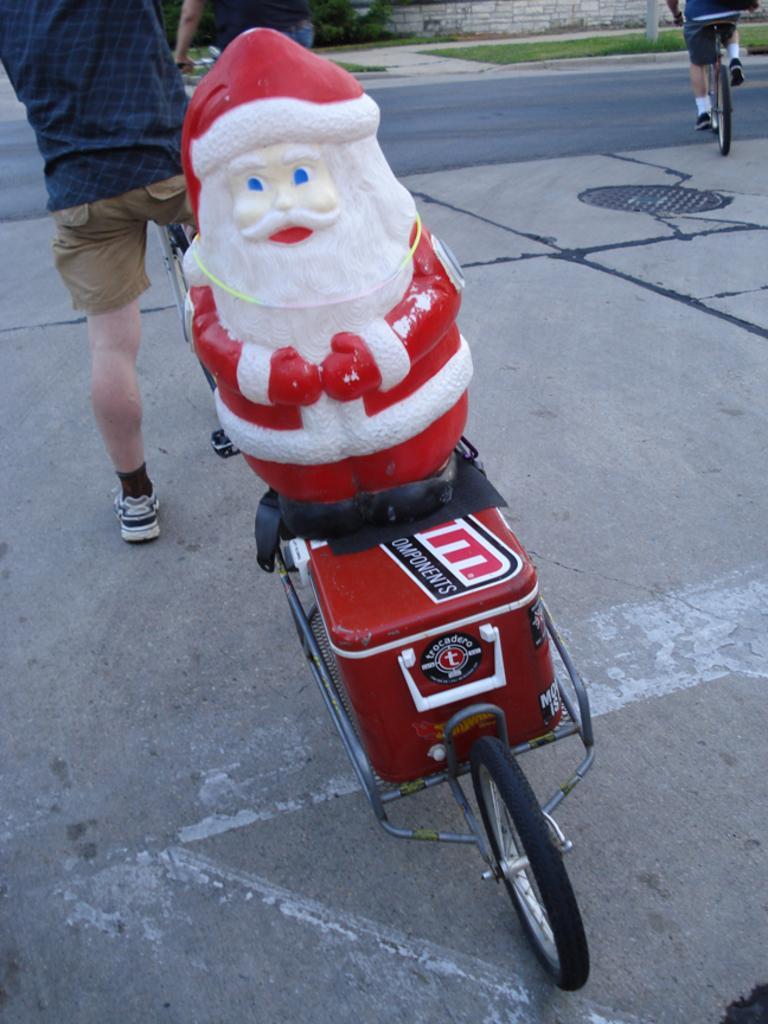How would you summarize this image in a sentence or two? At the bottom of the picture, we see a trolley on which a red color box and a toy of a Santa Claus are placed. Behind that, we see a bicycle and a man in the blue T-shirt is standing. In the right top, we see a man riding the bicycle. At the bottom, we see the road. In the background, we see the grass, trees, poles and a wall. 